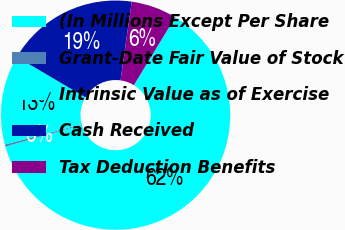Convert chart. <chart><loc_0><loc_0><loc_500><loc_500><pie_chart><fcel>(In Millions Except Per Share<fcel>Grant-Date Fair Value of Stock<fcel>Intrinsic Value as of Exercise<fcel>Cash Received<fcel>Tax Deduction Benefits<nl><fcel>61.87%<fcel>0.29%<fcel>12.61%<fcel>18.77%<fcel>6.45%<nl></chart> 